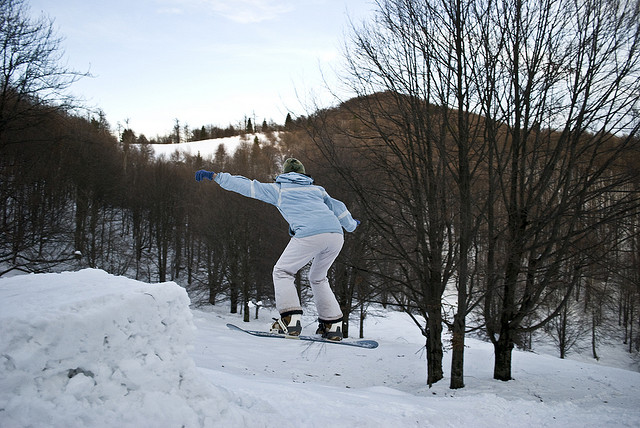<image>What type of trees is the lady leaning against? I am not sure about the type of tree the lady is leaning against. It can be oak, birch, spruce, or elm. What type of trees is the lady leaning against? I am not sure what type of trees the lady is leaning against. It can be oak or birch or spruce. 